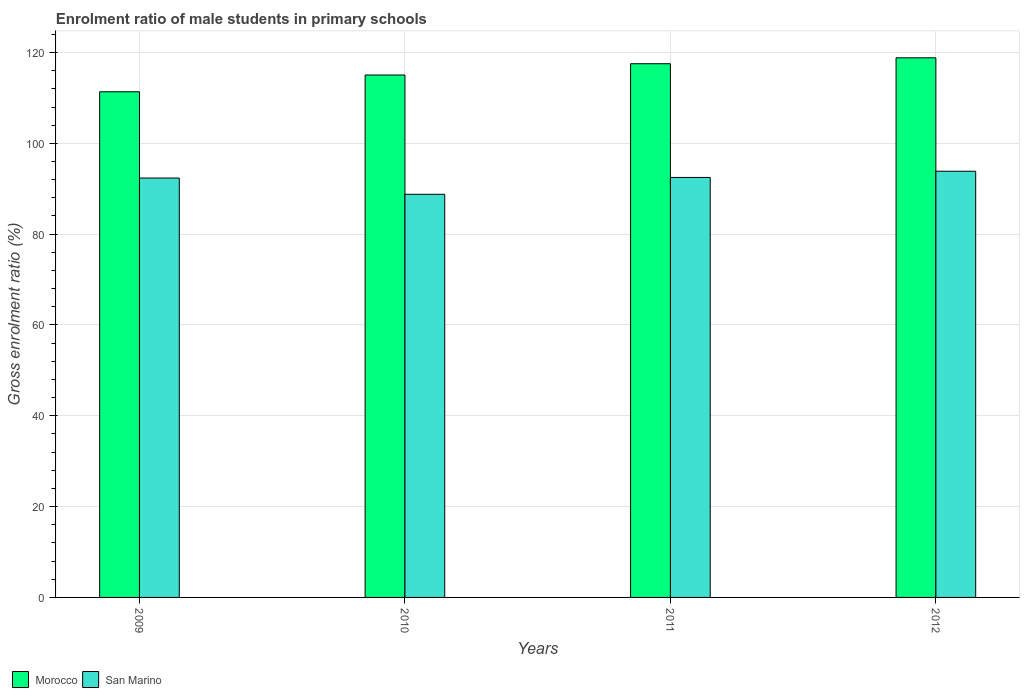How many groups of bars are there?
Keep it short and to the point. 4. Are the number of bars per tick equal to the number of legend labels?
Offer a terse response. Yes. How many bars are there on the 3rd tick from the left?
Your response must be concise. 2. What is the enrolment ratio of male students in primary schools in Morocco in 2012?
Offer a terse response. 118.84. Across all years, what is the maximum enrolment ratio of male students in primary schools in Morocco?
Provide a succinct answer. 118.84. Across all years, what is the minimum enrolment ratio of male students in primary schools in Morocco?
Keep it short and to the point. 111.36. What is the total enrolment ratio of male students in primary schools in Morocco in the graph?
Keep it short and to the point. 462.78. What is the difference between the enrolment ratio of male students in primary schools in San Marino in 2009 and that in 2010?
Your answer should be very brief. 3.58. What is the difference between the enrolment ratio of male students in primary schools in Morocco in 2009 and the enrolment ratio of male students in primary schools in San Marino in 2012?
Offer a terse response. 17.5. What is the average enrolment ratio of male students in primary schools in San Marino per year?
Offer a very short reply. 91.87. In the year 2012, what is the difference between the enrolment ratio of male students in primary schools in Morocco and enrolment ratio of male students in primary schools in San Marino?
Your answer should be compact. 24.98. What is the ratio of the enrolment ratio of male students in primary schools in Morocco in 2011 to that in 2012?
Provide a succinct answer. 0.99. Is the difference between the enrolment ratio of male students in primary schools in Morocco in 2010 and 2012 greater than the difference between the enrolment ratio of male students in primary schools in San Marino in 2010 and 2012?
Make the answer very short. Yes. What is the difference between the highest and the second highest enrolment ratio of male students in primary schools in San Marino?
Give a very brief answer. 1.37. What is the difference between the highest and the lowest enrolment ratio of male students in primary schools in San Marino?
Your answer should be compact. 5.08. Is the sum of the enrolment ratio of male students in primary schools in San Marino in 2009 and 2011 greater than the maximum enrolment ratio of male students in primary schools in Morocco across all years?
Make the answer very short. Yes. What does the 2nd bar from the left in 2012 represents?
Offer a very short reply. San Marino. What does the 2nd bar from the right in 2009 represents?
Keep it short and to the point. Morocco. What is the difference between two consecutive major ticks on the Y-axis?
Ensure brevity in your answer.  20. Are the values on the major ticks of Y-axis written in scientific E-notation?
Ensure brevity in your answer.  No. Where does the legend appear in the graph?
Your response must be concise. Bottom left. How are the legend labels stacked?
Ensure brevity in your answer.  Horizontal. What is the title of the graph?
Give a very brief answer. Enrolment ratio of male students in primary schools. What is the label or title of the Y-axis?
Keep it short and to the point. Gross enrolment ratio (%). What is the Gross enrolment ratio (%) of Morocco in 2009?
Provide a short and direct response. 111.36. What is the Gross enrolment ratio (%) in San Marino in 2009?
Keep it short and to the point. 92.36. What is the Gross enrolment ratio (%) of Morocco in 2010?
Offer a terse response. 115.05. What is the Gross enrolment ratio (%) of San Marino in 2010?
Provide a short and direct response. 88.78. What is the Gross enrolment ratio (%) in Morocco in 2011?
Offer a terse response. 117.53. What is the Gross enrolment ratio (%) of San Marino in 2011?
Provide a succinct answer. 92.49. What is the Gross enrolment ratio (%) of Morocco in 2012?
Give a very brief answer. 118.84. What is the Gross enrolment ratio (%) of San Marino in 2012?
Make the answer very short. 93.86. Across all years, what is the maximum Gross enrolment ratio (%) in Morocco?
Offer a terse response. 118.84. Across all years, what is the maximum Gross enrolment ratio (%) of San Marino?
Offer a very short reply. 93.86. Across all years, what is the minimum Gross enrolment ratio (%) of Morocco?
Give a very brief answer. 111.36. Across all years, what is the minimum Gross enrolment ratio (%) of San Marino?
Provide a succinct answer. 88.78. What is the total Gross enrolment ratio (%) in Morocco in the graph?
Offer a very short reply. 462.78. What is the total Gross enrolment ratio (%) in San Marino in the graph?
Your response must be concise. 367.48. What is the difference between the Gross enrolment ratio (%) in Morocco in 2009 and that in 2010?
Offer a very short reply. -3.69. What is the difference between the Gross enrolment ratio (%) of San Marino in 2009 and that in 2010?
Offer a terse response. 3.58. What is the difference between the Gross enrolment ratio (%) of Morocco in 2009 and that in 2011?
Your response must be concise. -6.17. What is the difference between the Gross enrolment ratio (%) in San Marino in 2009 and that in 2011?
Provide a short and direct response. -0.13. What is the difference between the Gross enrolment ratio (%) of Morocco in 2009 and that in 2012?
Ensure brevity in your answer.  -7.48. What is the difference between the Gross enrolment ratio (%) in San Marino in 2009 and that in 2012?
Keep it short and to the point. -1.5. What is the difference between the Gross enrolment ratio (%) of Morocco in 2010 and that in 2011?
Ensure brevity in your answer.  -2.48. What is the difference between the Gross enrolment ratio (%) in San Marino in 2010 and that in 2011?
Your answer should be very brief. -3.71. What is the difference between the Gross enrolment ratio (%) in Morocco in 2010 and that in 2012?
Provide a succinct answer. -3.79. What is the difference between the Gross enrolment ratio (%) in San Marino in 2010 and that in 2012?
Offer a terse response. -5.08. What is the difference between the Gross enrolment ratio (%) of Morocco in 2011 and that in 2012?
Your answer should be compact. -1.3. What is the difference between the Gross enrolment ratio (%) of San Marino in 2011 and that in 2012?
Your answer should be compact. -1.37. What is the difference between the Gross enrolment ratio (%) of Morocco in 2009 and the Gross enrolment ratio (%) of San Marino in 2010?
Your answer should be very brief. 22.58. What is the difference between the Gross enrolment ratio (%) of Morocco in 2009 and the Gross enrolment ratio (%) of San Marino in 2011?
Ensure brevity in your answer.  18.87. What is the difference between the Gross enrolment ratio (%) of Morocco in 2009 and the Gross enrolment ratio (%) of San Marino in 2012?
Your response must be concise. 17.5. What is the difference between the Gross enrolment ratio (%) in Morocco in 2010 and the Gross enrolment ratio (%) in San Marino in 2011?
Make the answer very short. 22.56. What is the difference between the Gross enrolment ratio (%) in Morocco in 2010 and the Gross enrolment ratio (%) in San Marino in 2012?
Offer a terse response. 21.19. What is the difference between the Gross enrolment ratio (%) of Morocco in 2011 and the Gross enrolment ratio (%) of San Marino in 2012?
Your answer should be very brief. 23.67. What is the average Gross enrolment ratio (%) in Morocco per year?
Your answer should be compact. 115.69. What is the average Gross enrolment ratio (%) in San Marino per year?
Your response must be concise. 91.87. In the year 2009, what is the difference between the Gross enrolment ratio (%) of Morocco and Gross enrolment ratio (%) of San Marino?
Offer a terse response. 19. In the year 2010, what is the difference between the Gross enrolment ratio (%) of Morocco and Gross enrolment ratio (%) of San Marino?
Provide a short and direct response. 26.27. In the year 2011, what is the difference between the Gross enrolment ratio (%) in Morocco and Gross enrolment ratio (%) in San Marino?
Offer a very short reply. 25.04. In the year 2012, what is the difference between the Gross enrolment ratio (%) in Morocco and Gross enrolment ratio (%) in San Marino?
Ensure brevity in your answer.  24.98. What is the ratio of the Gross enrolment ratio (%) in Morocco in 2009 to that in 2010?
Ensure brevity in your answer.  0.97. What is the ratio of the Gross enrolment ratio (%) in San Marino in 2009 to that in 2010?
Provide a succinct answer. 1.04. What is the ratio of the Gross enrolment ratio (%) of Morocco in 2009 to that in 2011?
Provide a succinct answer. 0.95. What is the ratio of the Gross enrolment ratio (%) of Morocco in 2009 to that in 2012?
Provide a succinct answer. 0.94. What is the ratio of the Gross enrolment ratio (%) of San Marino in 2009 to that in 2012?
Your answer should be very brief. 0.98. What is the ratio of the Gross enrolment ratio (%) in Morocco in 2010 to that in 2011?
Make the answer very short. 0.98. What is the ratio of the Gross enrolment ratio (%) in San Marino in 2010 to that in 2011?
Ensure brevity in your answer.  0.96. What is the ratio of the Gross enrolment ratio (%) of Morocco in 2010 to that in 2012?
Make the answer very short. 0.97. What is the ratio of the Gross enrolment ratio (%) of San Marino in 2010 to that in 2012?
Your answer should be very brief. 0.95. What is the ratio of the Gross enrolment ratio (%) in Morocco in 2011 to that in 2012?
Provide a short and direct response. 0.99. What is the ratio of the Gross enrolment ratio (%) of San Marino in 2011 to that in 2012?
Your answer should be compact. 0.99. What is the difference between the highest and the second highest Gross enrolment ratio (%) of Morocco?
Provide a short and direct response. 1.3. What is the difference between the highest and the second highest Gross enrolment ratio (%) in San Marino?
Ensure brevity in your answer.  1.37. What is the difference between the highest and the lowest Gross enrolment ratio (%) of Morocco?
Give a very brief answer. 7.48. What is the difference between the highest and the lowest Gross enrolment ratio (%) in San Marino?
Make the answer very short. 5.08. 